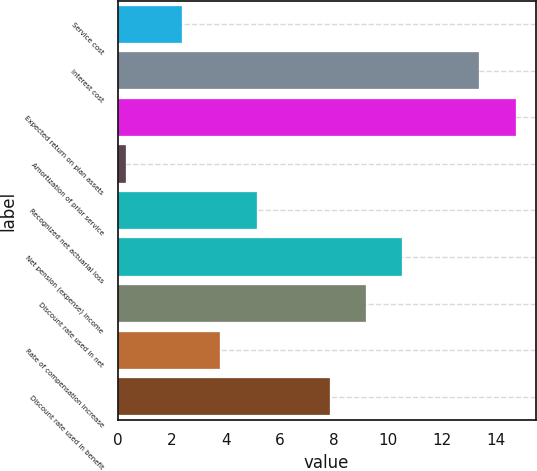<chart> <loc_0><loc_0><loc_500><loc_500><bar_chart><fcel>Service cost<fcel>Interest cost<fcel>Expected return on plan assets<fcel>Amortization of prior service<fcel>Recognized net actuarial loss<fcel>Net pension (expense) income<fcel>Discount rate used in net<fcel>Rate of compensation increase<fcel>Discount rate used in benefit<nl><fcel>2.4<fcel>13.4<fcel>14.75<fcel>0.3<fcel>5.15<fcel>10.55<fcel>9.2<fcel>3.8<fcel>7.85<nl></chart> 